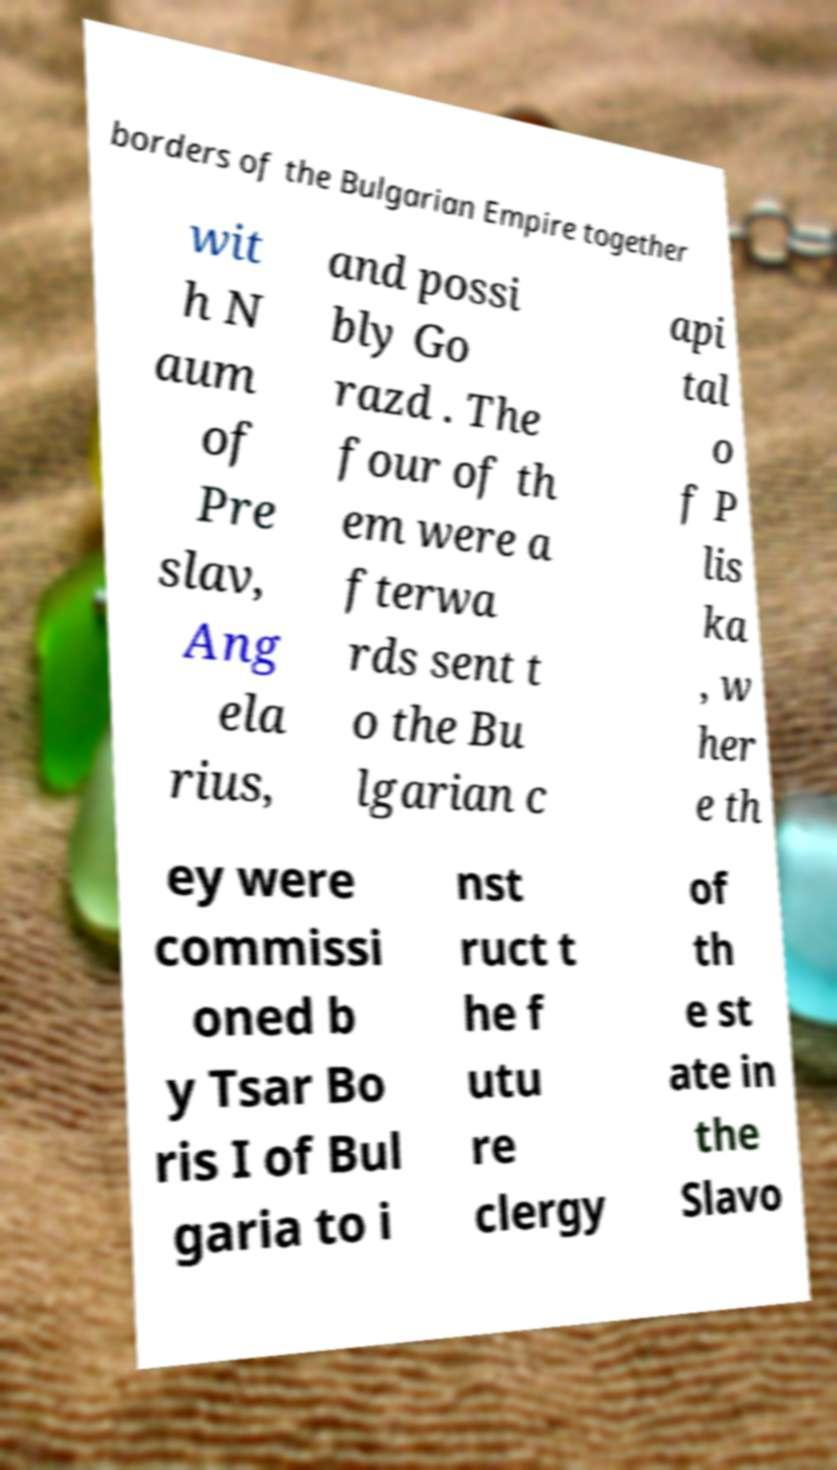Please identify and transcribe the text found in this image. borders of the Bulgarian Empire together wit h N aum of Pre slav, Ang ela rius, and possi bly Go razd . The four of th em were a fterwa rds sent t o the Bu lgarian c api tal o f P lis ka , w her e th ey were commissi oned b y Tsar Bo ris I of Bul garia to i nst ruct t he f utu re clergy of th e st ate in the Slavo 